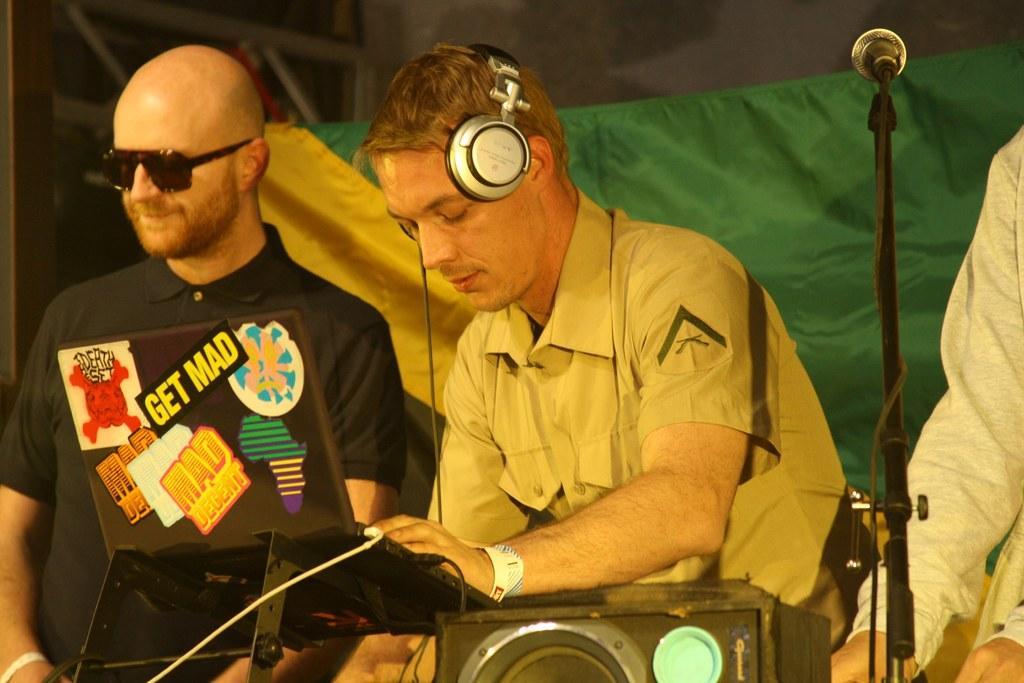In one or two sentences, can you explain what this image depicts? In this picture, we can see three people are standing on the path and in front of the people there is a machine and a microphone with stand and behind the people there is a cloth and other things. 